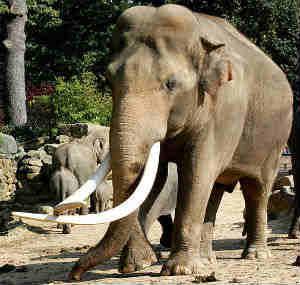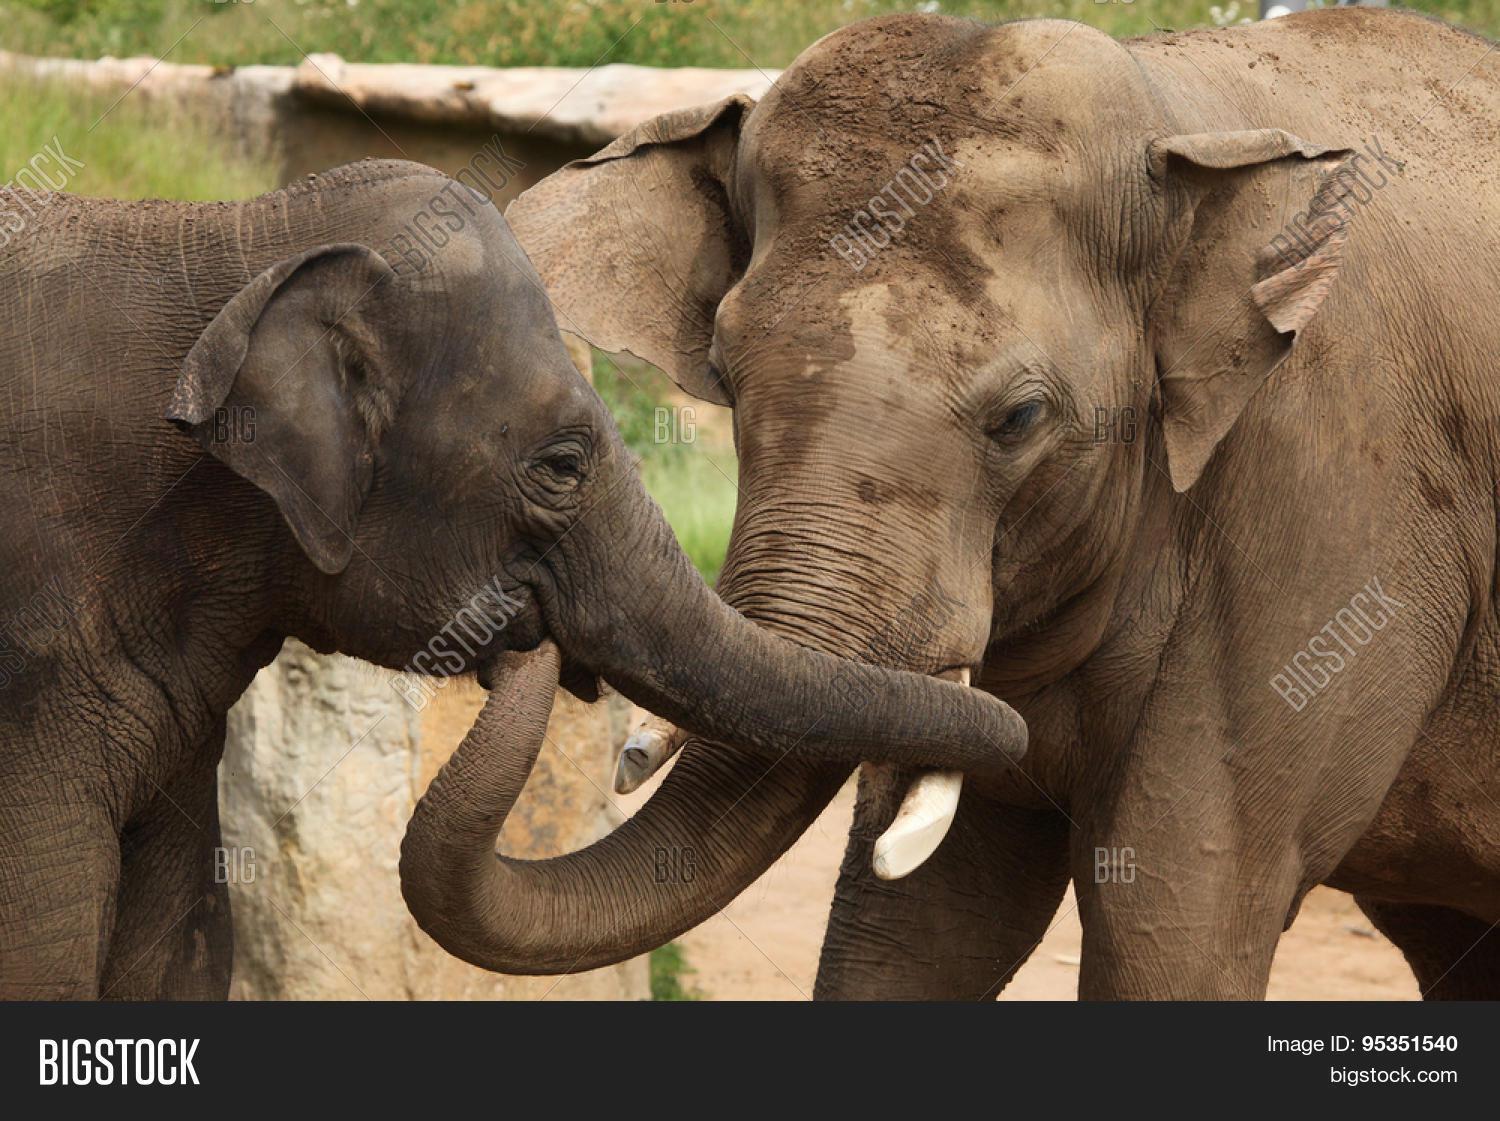The first image is the image on the left, the second image is the image on the right. Analyze the images presented: Is the assertion "there is one elephant on the left image" valid? Answer yes or no. Yes. 